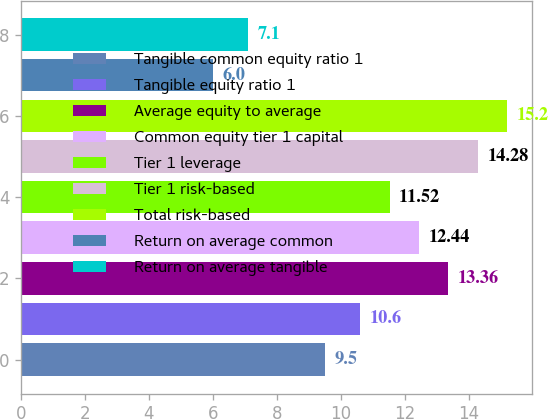<chart> <loc_0><loc_0><loc_500><loc_500><bar_chart><fcel>Tangible common equity ratio 1<fcel>Tangible equity ratio 1<fcel>Average equity to average<fcel>Common equity tier 1 capital<fcel>Tier 1 leverage<fcel>Tier 1 risk-based<fcel>Total risk-based<fcel>Return on average common<fcel>Return on average tangible<nl><fcel>9.5<fcel>10.6<fcel>13.36<fcel>12.44<fcel>11.52<fcel>14.28<fcel>15.2<fcel>6<fcel>7.1<nl></chart> 